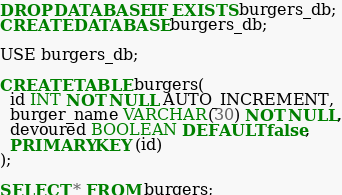<code> <loc_0><loc_0><loc_500><loc_500><_SQL_>DROP DATABASE IF EXISTS burgers_db;
CREATE DATABASE burgers_db;

USE burgers_db;

CREATE TABLE burgers(
  id INT NOT NULL AUTO_INCREMENT,
  burger_name VARCHAR(30) NOT NULL,
  devoured BOOLEAN DEFAULT false,
  PRIMARY KEY (id)
);

SELECT * FROM burgers;</code> 